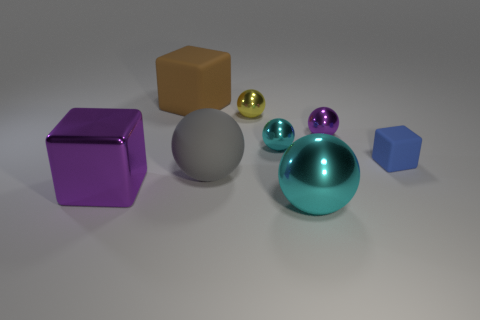Subtract all purple metal balls. How many balls are left? 4 Subtract all purple balls. How many balls are left? 4 Subtract all green balls. Subtract all yellow cylinders. How many balls are left? 5 Add 1 tiny matte things. How many objects exist? 9 Subtract all cubes. How many objects are left? 5 Add 4 tiny rubber blocks. How many tiny rubber blocks are left? 5 Add 2 large brown metallic balls. How many large brown metallic balls exist? 2 Subtract 0 gray cylinders. How many objects are left? 8 Subtract all small objects. Subtract all large spheres. How many objects are left? 2 